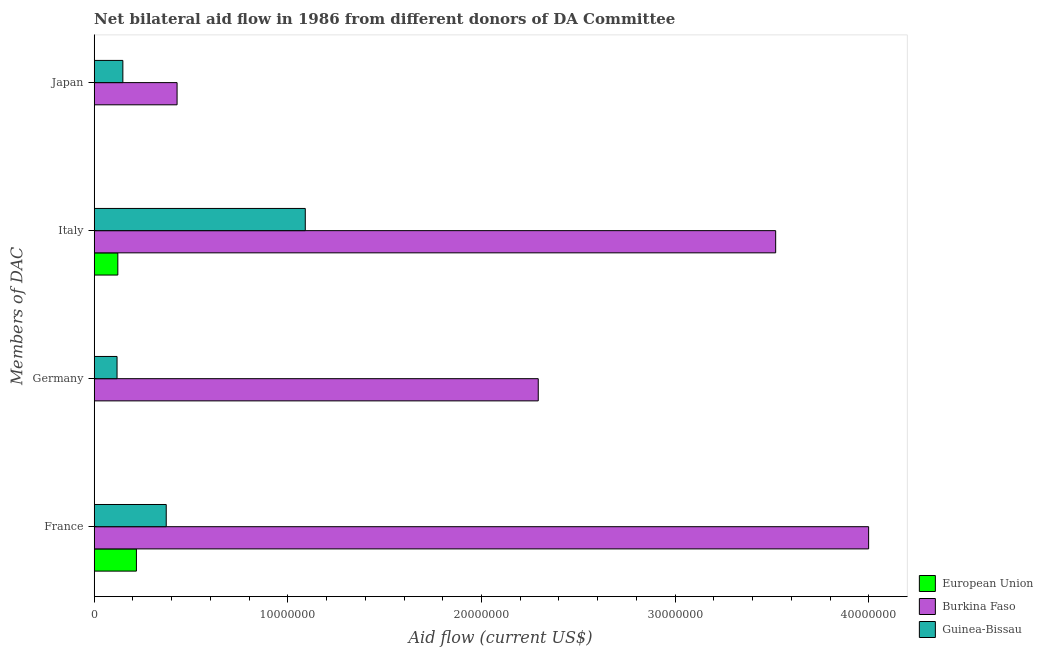How many groups of bars are there?
Keep it short and to the point. 4. Are the number of bars on each tick of the Y-axis equal?
Provide a succinct answer. No. How many bars are there on the 2nd tick from the top?
Ensure brevity in your answer.  3. How many bars are there on the 4th tick from the bottom?
Offer a terse response. 3. What is the amount of aid given by japan in Guinea-Bissau?
Offer a very short reply. 1.48e+06. Across all countries, what is the maximum amount of aid given by germany?
Your answer should be very brief. 2.29e+07. Across all countries, what is the minimum amount of aid given by germany?
Keep it short and to the point. 0. In which country was the amount of aid given by germany maximum?
Make the answer very short. Burkina Faso. What is the total amount of aid given by france in the graph?
Ensure brevity in your answer.  4.59e+07. What is the difference between the amount of aid given by japan in Burkina Faso and that in European Union?
Ensure brevity in your answer.  4.27e+06. What is the difference between the amount of aid given by italy in European Union and the amount of aid given by germany in Guinea-Bissau?
Keep it short and to the point. 4.00e+04. What is the average amount of aid given by germany per country?
Ensure brevity in your answer.  8.04e+06. What is the difference between the amount of aid given by france and amount of aid given by germany in Guinea-Bissau?
Your response must be concise. 2.54e+06. What is the ratio of the amount of aid given by japan in European Union to that in Guinea-Bissau?
Give a very brief answer. 0.01. Is the amount of aid given by germany in Guinea-Bissau less than that in Burkina Faso?
Offer a terse response. Yes. Is the difference between the amount of aid given by germany in Guinea-Bissau and Burkina Faso greater than the difference between the amount of aid given by japan in Guinea-Bissau and Burkina Faso?
Offer a very short reply. No. What is the difference between the highest and the second highest amount of aid given by italy?
Give a very brief answer. 2.43e+07. What is the difference between the highest and the lowest amount of aid given by italy?
Your answer should be compact. 3.40e+07. Is the sum of the amount of aid given by germany in Burkina Faso and Guinea-Bissau greater than the maximum amount of aid given by france across all countries?
Provide a succinct answer. No. Is it the case that in every country, the sum of the amount of aid given by france and amount of aid given by germany is greater than the amount of aid given by italy?
Provide a short and direct response. No. How many bars are there?
Provide a succinct answer. 11. Are all the bars in the graph horizontal?
Give a very brief answer. Yes. What is the difference between two consecutive major ticks on the X-axis?
Ensure brevity in your answer.  1.00e+07. Where does the legend appear in the graph?
Your answer should be compact. Bottom right. How are the legend labels stacked?
Your answer should be compact. Vertical. What is the title of the graph?
Keep it short and to the point. Net bilateral aid flow in 1986 from different donors of DA Committee. Does "Ukraine" appear as one of the legend labels in the graph?
Your answer should be very brief. No. What is the label or title of the X-axis?
Your answer should be compact. Aid flow (current US$). What is the label or title of the Y-axis?
Offer a very short reply. Members of DAC. What is the Aid flow (current US$) in European Union in France?
Provide a short and direct response. 2.18e+06. What is the Aid flow (current US$) in Burkina Faso in France?
Your response must be concise. 4.00e+07. What is the Aid flow (current US$) of Guinea-Bissau in France?
Offer a very short reply. 3.72e+06. What is the Aid flow (current US$) of European Union in Germany?
Give a very brief answer. 0. What is the Aid flow (current US$) of Burkina Faso in Germany?
Keep it short and to the point. 2.29e+07. What is the Aid flow (current US$) in Guinea-Bissau in Germany?
Keep it short and to the point. 1.18e+06. What is the Aid flow (current US$) of European Union in Italy?
Your response must be concise. 1.22e+06. What is the Aid flow (current US$) of Burkina Faso in Italy?
Ensure brevity in your answer.  3.52e+07. What is the Aid flow (current US$) in Guinea-Bissau in Italy?
Give a very brief answer. 1.09e+07. What is the Aid flow (current US$) in Burkina Faso in Japan?
Your answer should be very brief. 4.28e+06. What is the Aid flow (current US$) of Guinea-Bissau in Japan?
Ensure brevity in your answer.  1.48e+06. Across all Members of DAC, what is the maximum Aid flow (current US$) in European Union?
Make the answer very short. 2.18e+06. Across all Members of DAC, what is the maximum Aid flow (current US$) in Burkina Faso?
Provide a succinct answer. 4.00e+07. Across all Members of DAC, what is the maximum Aid flow (current US$) in Guinea-Bissau?
Keep it short and to the point. 1.09e+07. Across all Members of DAC, what is the minimum Aid flow (current US$) in European Union?
Provide a short and direct response. 0. Across all Members of DAC, what is the minimum Aid flow (current US$) in Burkina Faso?
Ensure brevity in your answer.  4.28e+06. Across all Members of DAC, what is the minimum Aid flow (current US$) in Guinea-Bissau?
Offer a very short reply. 1.18e+06. What is the total Aid flow (current US$) in European Union in the graph?
Keep it short and to the point. 3.41e+06. What is the total Aid flow (current US$) of Burkina Faso in the graph?
Give a very brief answer. 1.02e+08. What is the total Aid flow (current US$) of Guinea-Bissau in the graph?
Offer a terse response. 1.73e+07. What is the difference between the Aid flow (current US$) of Burkina Faso in France and that in Germany?
Your answer should be compact. 1.71e+07. What is the difference between the Aid flow (current US$) in Guinea-Bissau in France and that in Germany?
Provide a short and direct response. 2.54e+06. What is the difference between the Aid flow (current US$) in European Union in France and that in Italy?
Give a very brief answer. 9.60e+05. What is the difference between the Aid flow (current US$) of Burkina Faso in France and that in Italy?
Give a very brief answer. 4.80e+06. What is the difference between the Aid flow (current US$) in Guinea-Bissau in France and that in Italy?
Give a very brief answer. -7.18e+06. What is the difference between the Aid flow (current US$) in European Union in France and that in Japan?
Give a very brief answer. 2.17e+06. What is the difference between the Aid flow (current US$) in Burkina Faso in France and that in Japan?
Offer a terse response. 3.57e+07. What is the difference between the Aid flow (current US$) of Guinea-Bissau in France and that in Japan?
Ensure brevity in your answer.  2.24e+06. What is the difference between the Aid flow (current US$) of Burkina Faso in Germany and that in Italy?
Provide a succinct answer. -1.23e+07. What is the difference between the Aid flow (current US$) in Guinea-Bissau in Germany and that in Italy?
Your answer should be very brief. -9.72e+06. What is the difference between the Aid flow (current US$) in Burkina Faso in Germany and that in Japan?
Your answer should be compact. 1.86e+07. What is the difference between the Aid flow (current US$) of European Union in Italy and that in Japan?
Keep it short and to the point. 1.21e+06. What is the difference between the Aid flow (current US$) in Burkina Faso in Italy and that in Japan?
Provide a succinct answer. 3.09e+07. What is the difference between the Aid flow (current US$) of Guinea-Bissau in Italy and that in Japan?
Provide a short and direct response. 9.42e+06. What is the difference between the Aid flow (current US$) in European Union in France and the Aid flow (current US$) in Burkina Faso in Germany?
Your answer should be compact. -2.08e+07. What is the difference between the Aid flow (current US$) of European Union in France and the Aid flow (current US$) of Guinea-Bissau in Germany?
Provide a short and direct response. 1.00e+06. What is the difference between the Aid flow (current US$) in Burkina Faso in France and the Aid flow (current US$) in Guinea-Bissau in Germany?
Offer a very short reply. 3.88e+07. What is the difference between the Aid flow (current US$) of European Union in France and the Aid flow (current US$) of Burkina Faso in Italy?
Make the answer very short. -3.30e+07. What is the difference between the Aid flow (current US$) of European Union in France and the Aid flow (current US$) of Guinea-Bissau in Italy?
Ensure brevity in your answer.  -8.72e+06. What is the difference between the Aid flow (current US$) of Burkina Faso in France and the Aid flow (current US$) of Guinea-Bissau in Italy?
Keep it short and to the point. 2.91e+07. What is the difference between the Aid flow (current US$) of European Union in France and the Aid flow (current US$) of Burkina Faso in Japan?
Keep it short and to the point. -2.10e+06. What is the difference between the Aid flow (current US$) of European Union in France and the Aid flow (current US$) of Guinea-Bissau in Japan?
Your answer should be compact. 7.00e+05. What is the difference between the Aid flow (current US$) in Burkina Faso in France and the Aid flow (current US$) in Guinea-Bissau in Japan?
Your answer should be compact. 3.85e+07. What is the difference between the Aid flow (current US$) in Burkina Faso in Germany and the Aid flow (current US$) in Guinea-Bissau in Italy?
Make the answer very short. 1.20e+07. What is the difference between the Aid flow (current US$) in Burkina Faso in Germany and the Aid flow (current US$) in Guinea-Bissau in Japan?
Offer a very short reply. 2.14e+07. What is the difference between the Aid flow (current US$) of European Union in Italy and the Aid flow (current US$) of Burkina Faso in Japan?
Your answer should be compact. -3.06e+06. What is the difference between the Aid flow (current US$) of European Union in Italy and the Aid flow (current US$) of Guinea-Bissau in Japan?
Keep it short and to the point. -2.60e+05. What is the difference between the Aid flow (current US$) in Burkina Faso in Italy and the Aid flow (current US$) in Guinea-Bissau in Japan?
Make the answer very short. 3.37e+07. What is the average Aid flow (current US$) in European Union per Members of DAC?
Offer a very short reply. 8.52e+05. What is the average Aid flow (current US$) of Burkina Faso per Members of DAC?
Provide a succinct answer. 2.56e+07. What is the average Aid flow (current US$) of Guinea-Bissau per Members of DAC?
Give a very brief answer. 4.32e+06. What is the difference between the Aid flow (current US$) in European Union and Aid flow (current US$) in Burkina Faso in France?
Your answer should be compact. -3.78e+07. What is the difference between the Aid flow (current US$) in European Union and Aid flow (current US$) in Guinea-Bissau in France?
Your response must be concise. -1.54e+06. What is the difference between the Aid flow (current US$) of Burkina Faso and Aid flow (current US$) of Guinea-Bissau in France?
Provide a succinct answer. 3.63e+07. What is the difference between the Aid flow (current US$) of Burkina Faso and Aid flow (current US$) of Guinea-Bissau in Germany?
Your response must be concise. 2.18e+07. What is the difference between the Aid flow (current US$) in European Union and Aid flow (current US$) in Burkina Faso in Italy?
Your answer should be compact. -3.40e+07. What is the difference between the Aid flow (current US$) in European Union and Aid flow (current US$) in Guinea-Bissau in Italy?
Provide a succinct answer. -9.68e+06. What is the difference between the Aid flow (current US$) in Burkina Faso and Aid flow (current US$) in Guinea-Bissau in Italy?
Offer a terse response. 2.43e+07. What is the difference between the Aid flow (current US$) of European Union and Aid flow (current US$) of Burkina Faso in Japan?
Your answer should be compact. -4.27e+06. What is the difference between the Aid flow (current US$) of European Union and Aid flow (current US$) of Guinea-Bissau in Japan?
Make the answer very short. -1.47e+06. What is the difference between the Aid flow (current US$) in Burkina Faso and Aid flow (current US$) in Guinea-Bissau in Japan?
Keep it short and to the point. 2.80e+06. What is the ratio of the Aid flow (current US$) of Burkina Faso in France to that in Germany?
Offer a very short reply. 1.74. What is the ratio of the Aid flow (current US$) of Guinea-Bissau in France to that in Germany?
Your response must be concise. 3.15. What is the ratio of the Aid flow (current US$) of European Union in France to that in Italy?
Your answer should be very brief. 1.79. What is the ratio of the Aid flow (current US$) of Burkina Faso in France to that in Italy?
Your answer should be very brief. 1.14. What is the ratio of the Aid flow (current US$) in Guinea-Bissau in France to that in Italy?
Your answer should be compact. 0.34. What is the ratio of the Aid flow (current US$) in European Union in France to that in Japan?
Ensure brevity in your answer.  218. What is the ratio of the Aid flow (current US$) of Burkina Faso in France to that in Japan?
Give a very brief answer. 9.34. What is the ratio of the Aid flow (current US$) in Guinea-Bissau in France to that in Japan?
Your answer should be compact. 2.51. What is the ratio of the Aid flow (current US$) in Burkina Faso in Germany to that in Italy?
Provide a short and direct response. 0.65. What is the ratio of the Aid flow (current US$) of Guinea-Bissau in Germany to that in Italy?
Offer a terse response. 0.11. What is the ratio of the Aid flow (current US$) of Burkina Faso in Germany to that in Japan?
Your answer should be compact. 5.36. What is the ratio of the Aid flow (current US$) in Guinea-Bissau in Germany to that in Japan?
Your answer should be very brief. 0.8. What is the ratio of the Aid flow (current US$) in European Union in Italy to that in Japan?
Offer a terse response. 122. What is the ratio of the Aid flow (current US$) in Burkina Faso in Italy to that in Japan?
Provide a succinct answer. 8.22. What is the ratio of the Aid flow (current US$) in Guinea-Bissau in Italy to that in Japan?
Your answer should be very brief. 7.36. What is the difference between the highest and the second highest Aid flow (current US$) in European Union?
Give a very brief answer. 9.60e+05. What is the difference between the highest and the second highest Aid flow (current US$) of Burkina Faso?
Your answer should be very brief. 4.80e+06. What is the difference between the highest and the second highest Aid flow (current US$) in Guinea-Bissau?
Keep it short and to the point. 7.18e+06. What is the difference between the highest and the lowest Aid flow (current US$) in European Union?
Your answer should be very brief. 2.18e+06. What is the difference between the highest and the lowest Aid flow (current US$) of Burkina Faso?
Keep it short and to the point. 3.57e+07. What is the difference between the highest and the lowest Aid flow (current US$) in Guinea-Bissau?
Your response must be concise. 9.72e+06. 